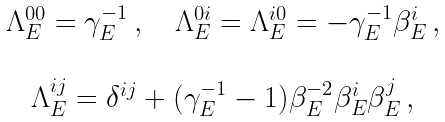<formula> <loc_0><loc_0><loc_500><loc_500>\begin{array} { c } \begin{array} { c c c } \Lambda _ { E } ^ { 0 0 } = \gamma _ { E } ^ { - 1 } \, , & & \Lambda _ { E } ^ { 0 i } = \Lambda _ { E } ^ { i 0 } = - \gamma _ { E } ^ { - 1 } \beta _ { E } ^ { i } \, , \end{array} \\ \\ \Lambda _ { E } ^ { i j } = \delta ^ { i j } + ( \gamma _ { E } ^ { - 1 } - 1 ) \beta _ { E } ^ { - 2 } \beta _ { E } ^ { i } \beta _ { E } ^ { j } \, , \end{array}</formula> 